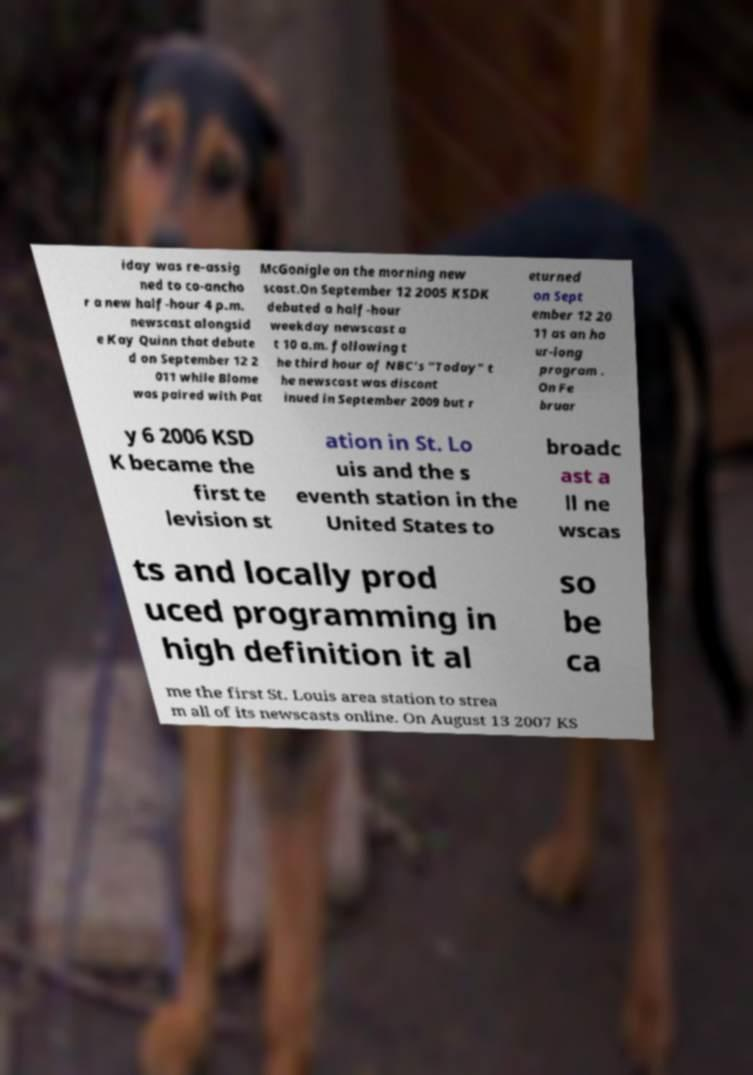Please identify and transcribe the text found in this image. iday was re-assig ned to co-ancho r a new half-hour 4 p.m. newscast alongsid e Kay Quinn that debute d on September 12 2 011 while Blome was paired with Pat McGonigle on the morning new scast.On September 12 2005 KSDK debuted a half-hour weekday newscast a t 10 a.m. following t he third hour of NBC's "Today" t he newscast was discont inued in September 2009 but r eturned on Sept ember 12 20 11 as an ho ur-long program . On Fe bruar y 6 2006 KSD K became the first te levision st ation in St. Lo uis and the s eventh station in the United States to broadc ast a ll ne wscas ts and locally prod uced programming in high definition it al so be ca me the first St. Louis area station to strea m all of its newscasts online. On August 13 2007 KS 